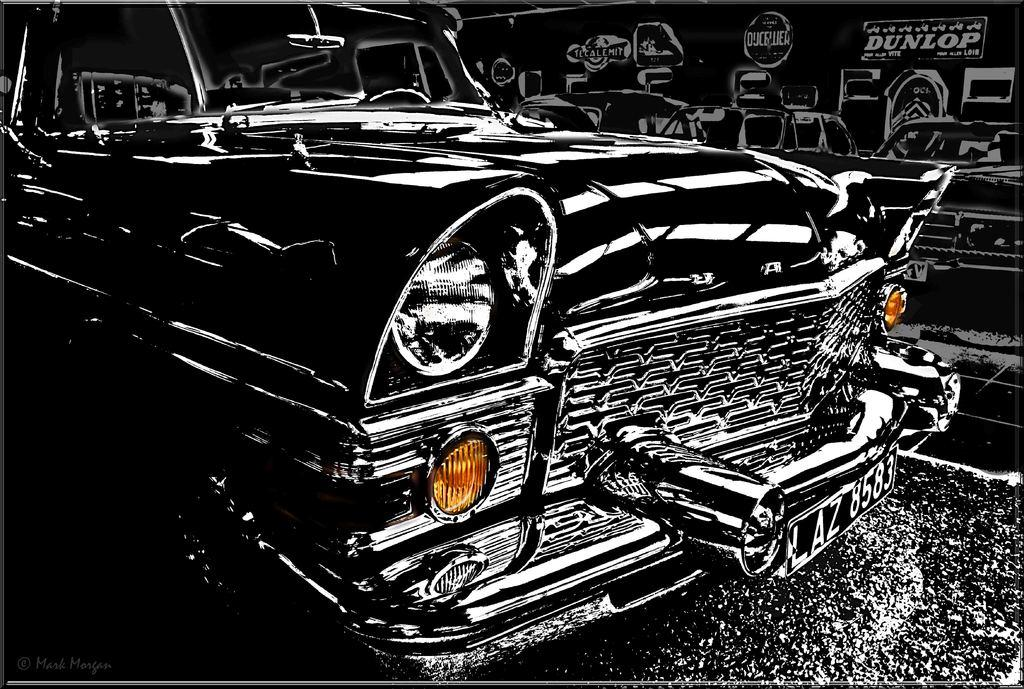What is depicted in the drawing in the image? There is a drawing of a car in the image. What can be seen beside the car in the image? There is a wall beside the car in the image. What is written or drawn on the wall in the image? There is text present on the wall in the image. How many goldfish are swimming in the alley in the image? There are no goldfish or alley present in the image; it features a drawing of a car and a wall with text. 